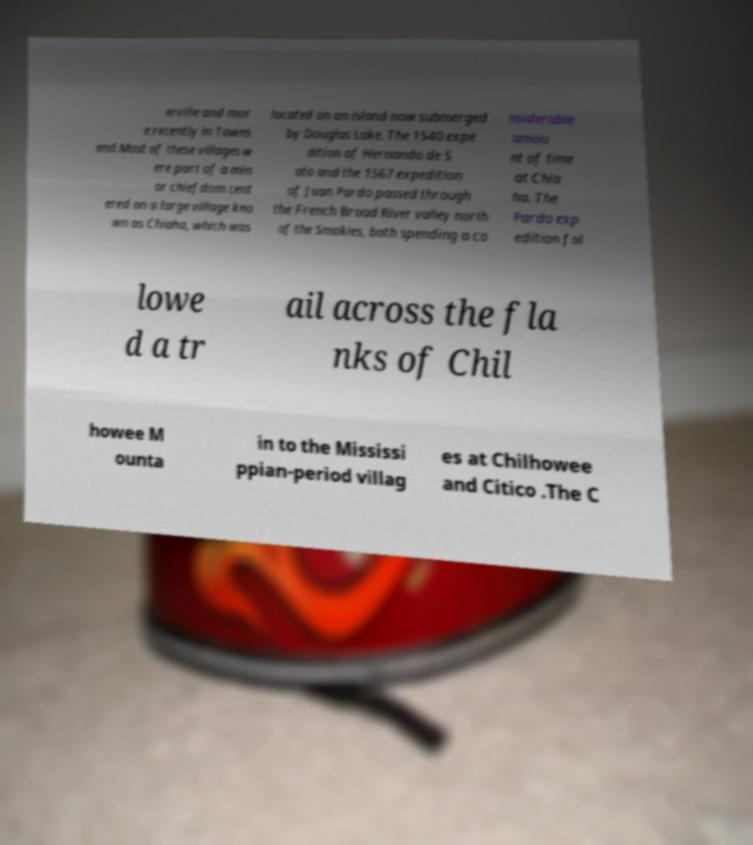Could you assist in decoding the text presented in this image and type it out clearly? erville and mor e recently in Towns end.Most of these villages w ere part of a min or chiefdom cent ered on a large village kno wn as Chiaha, which was located on an island now submerged by Douglas Lake. The 1540 expe dition of Hernando de S oto and the 1567 expedition of Juan Pardo passed through the French Broad River valley north of the Smokies, both spending a co nsiderable amou nt of time at Chia ha. The Pardo exp edition fol lowe d a tr ail across the fla nks of Chil howee M ounta in to the Mississi ppian-period villag es at Chilhowee and Citico .The C 